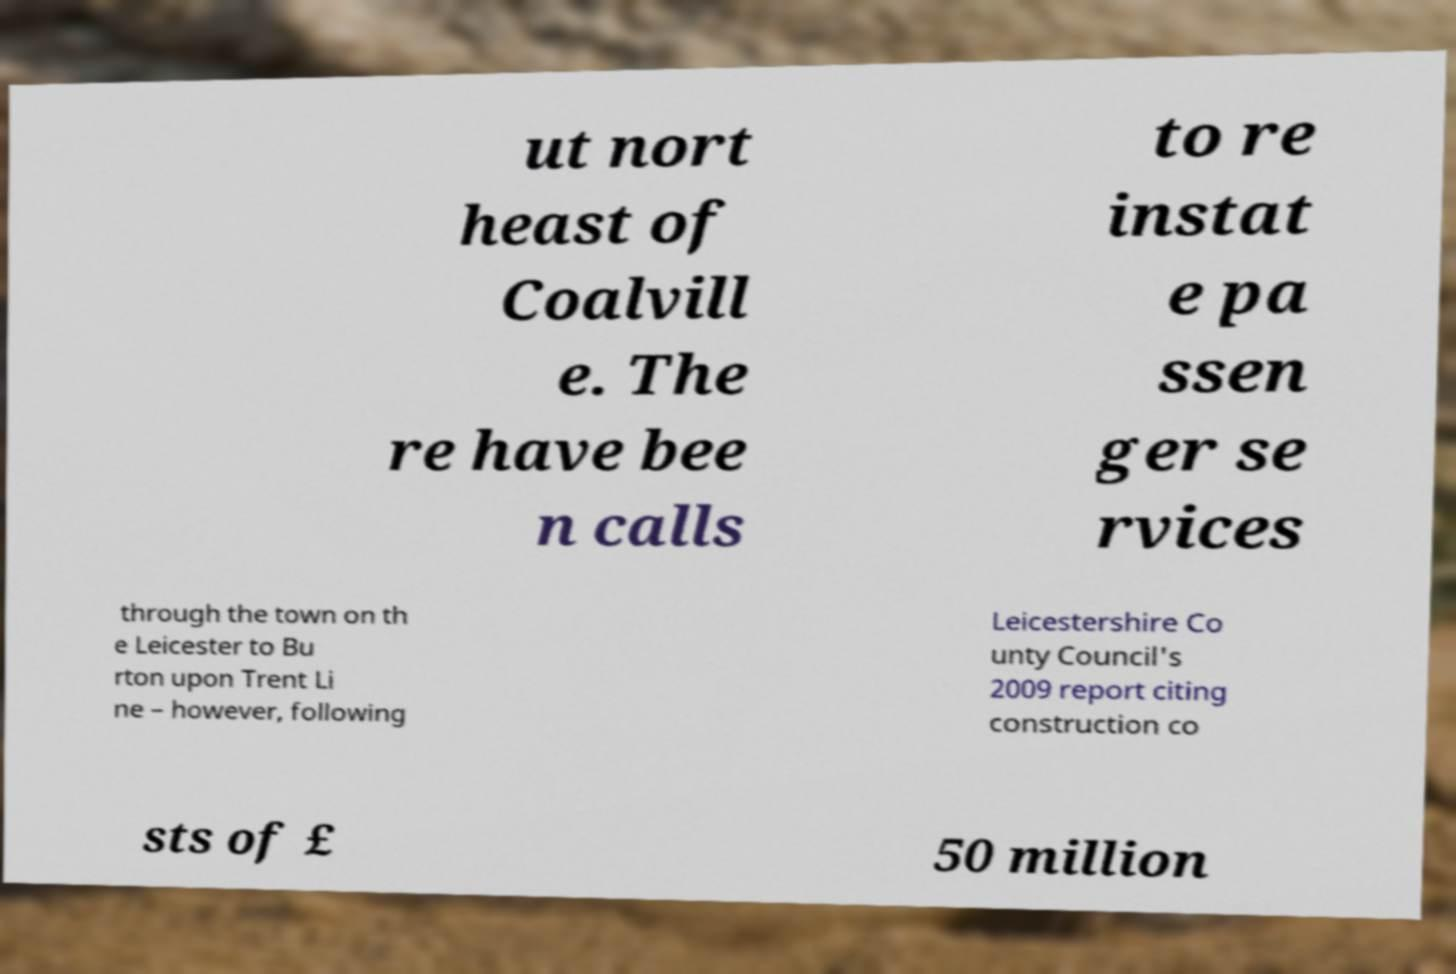I need the written content from this picture converted into text. Can you do that? ut nort heast of Coalvill e. The re have bee n calls to re instat e pa ssen ger se rvices through the town on th e Leicester to Bu rton upon Trent Li ne – however, following Leicestershire Co unty Council's 2009 report citing construction co sts of £ 50 million 